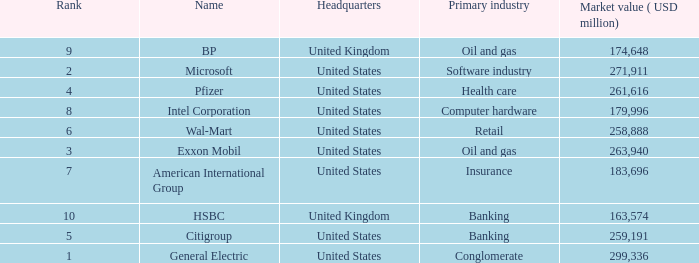Parse the table in full. {'header': ['Rank', 'Name', 'Headquarters', 'Primary industry', 'Market value ( USD million)'], 'rows': [['9', 'BP', 'United Kingdom', 'Oil and gas', '174,648'], ['2', 'Microsoft', 'United States', 'Software industry', '271,911'], ['4', 'Pfizer', 'United States', 'Health care', '261,616'], ['8', 'Intel Corporation', 'United States', 'Computer hardware', '179,996'], ['6', 'Wal-Mart', 'United States', 'Retail', '258,888'], ['3', 'Exxon Mobil', 'United States', 'Oil and gas', '263,940'], ['7', 'American International Group', 'United States', 'Insurance', '183,696'], ['10', 'HSBC', 'United Kingdom', 'Banking', '163,574'], ['5', 'Citigroup', 'United States', 'Banking', '259,191'], ['1', 'General Electric', 'United States', 'Conglomerate', '299,336']]} How many ranks have an industry of health care? 1.0. 